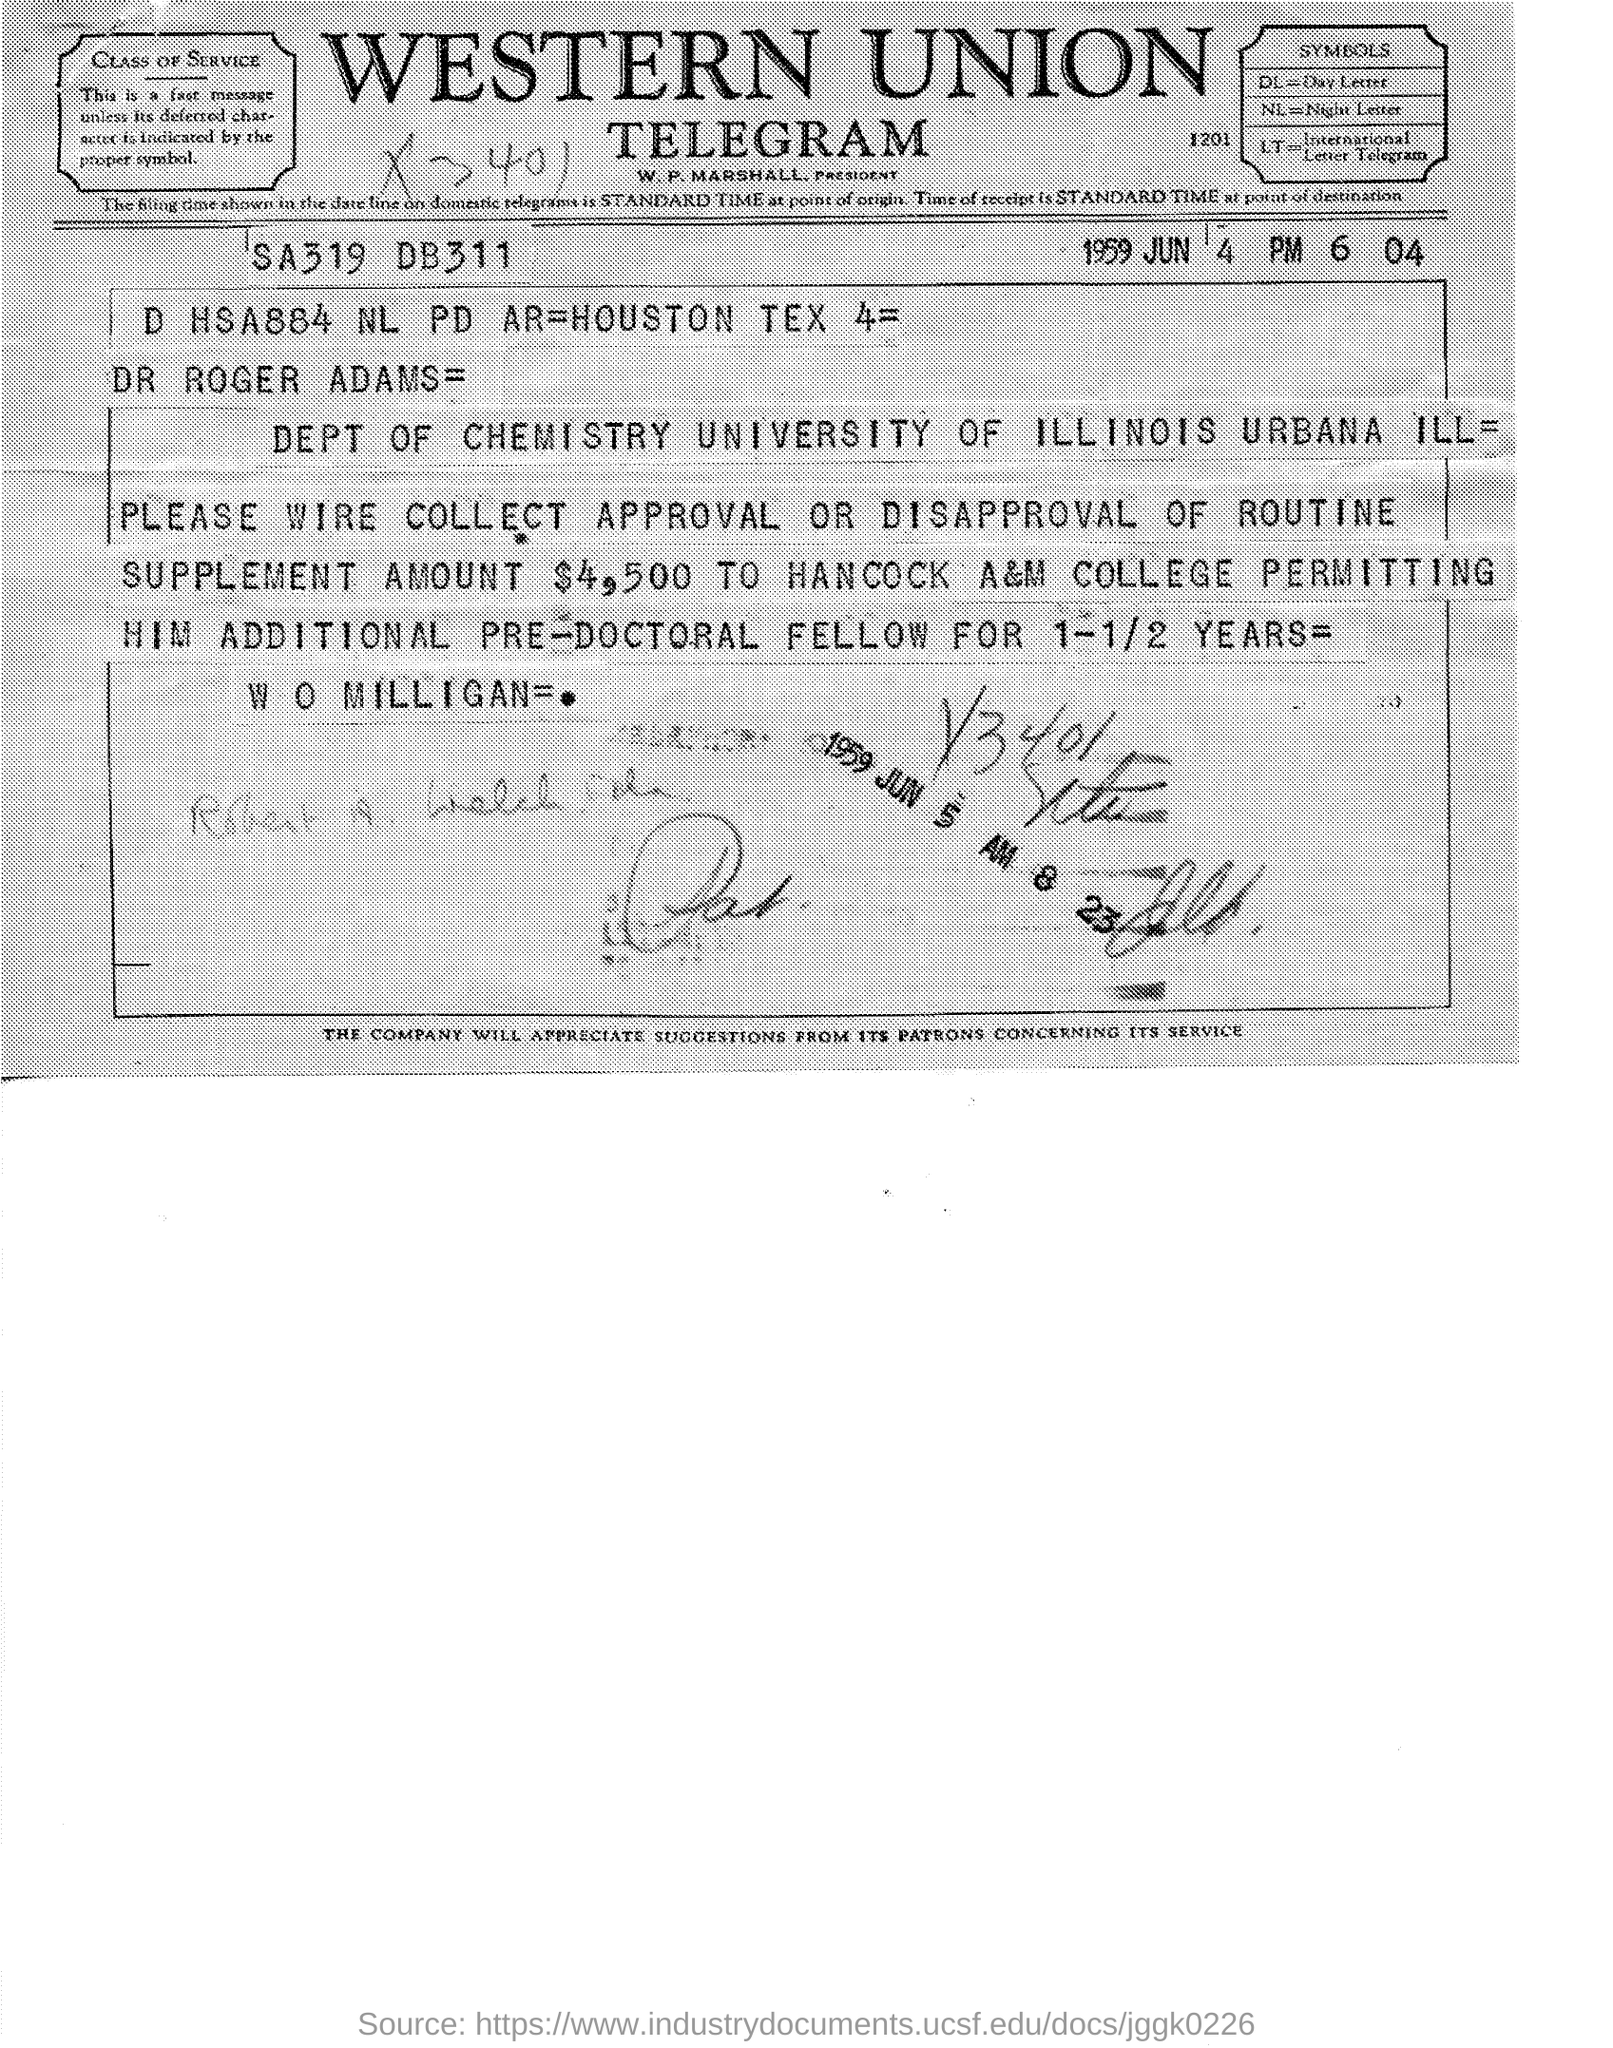Point out several critical features in this image. The routine supplement amount is $4,500. The document is dated June 4, 1959. Western Union is the firm mentioned at the top of the page. The department mentioned is the Department of Chemistry. 